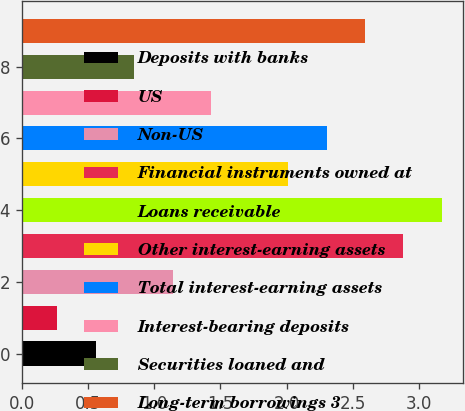Convert chart. <chart><loc_0><loc_0><loc_500><loc_500><bar_chart><fcel>Deposits with banks<fcel>US<fcel>Non-US<fcel>Financial instruments owned at<fcel>Loans receivable<fcel>Other interest-earning assets<fcel>Total interest-earning assets<fcel>Interest-bearing deposits<fcel>Securities loaned and<fcel>Long-term borrowings 3<nl><fcel>0.56<fcel>0.27<fcel>1.14<fcel>2.88<fcel>3.17<fcel>2.01<fcel>2.3<fcel>1.43<fcel>0.85<fcel>2.59<nl></chart> 